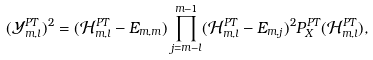Convert formula to latex. <formula><loc_0><loc_0><loc_500><loc_500>( \mathcal { Y } _ { m , l } ^ { P T } ) ^ { 2 } = ( \mathcal { H } ^ { P T } _ { m , l } - E _ { m , m } ) \prod _ { j = m - l } ^ { m - 1 } ( \mathcal { H } ^ { P T } _ { m , l } - E _ { m , j } ) ^ { 2 } P ^ { P T } _ { X } ( \mathcal { H } ^ { P T } _ { m , l } ) ,</formula> 